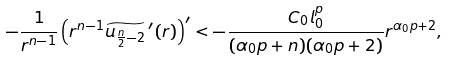<formula> <loc_0><loc_0><loc_500><loc_500>- \frac { 1 } { r ^ { n - 1 } } \left ( r ^ { n - 1 } \widetilde { u _ { \frac { n } { 2 } - 2 } } \, ^ { \prime } ( r ) \right ) ^ { \prime } < - \frac { C _ { 0 } l _ { 0 } ^ { p } } { ( \alpha _ { 0 } p + n ) ( \alpha _ { 0 } p + 2 ) } r ^ { \alpha _ { 0 } p + 2 } ,</formula> 